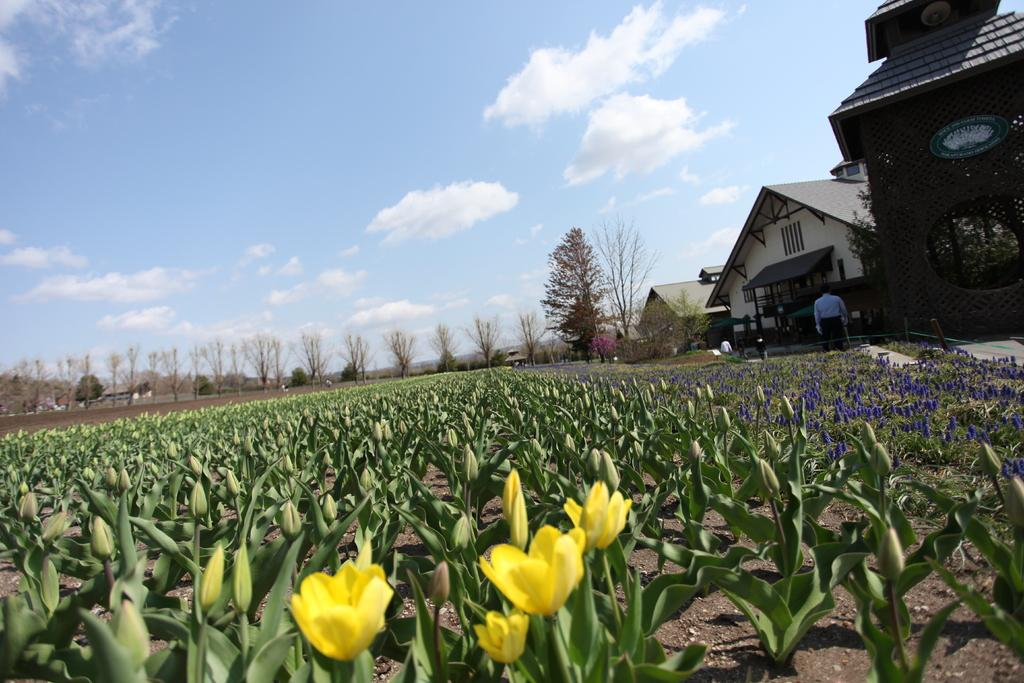What type of flowers can be seen on the plants in the image? The plants in the image have yellow and violet flowers. What structures are located in the right corner of the image? There are buildings in the right corner of the image. What type of vegetation is visible in the background of the image? There are trees in the background of the image. What type of music can be heard playing in the background of the image? There is no music present in the image; it only contains visual elements. 